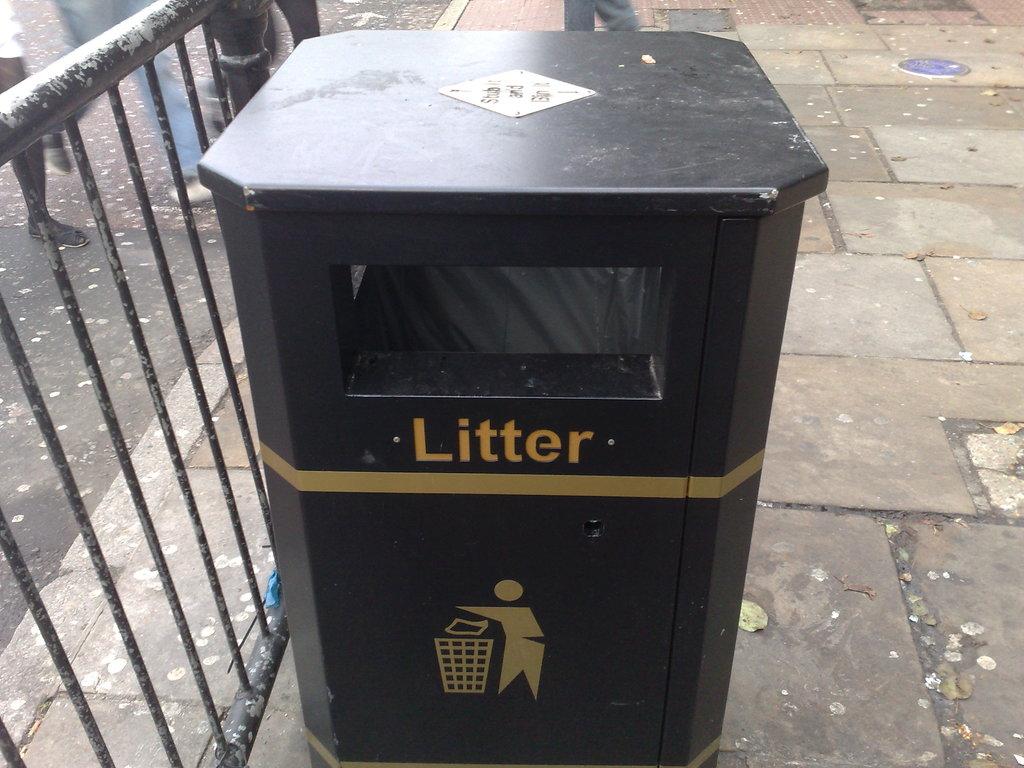What is this container designed to hold?
Make the answer very short. Litter. What does the text say on the can?
Give a very brief answer. Litter. 